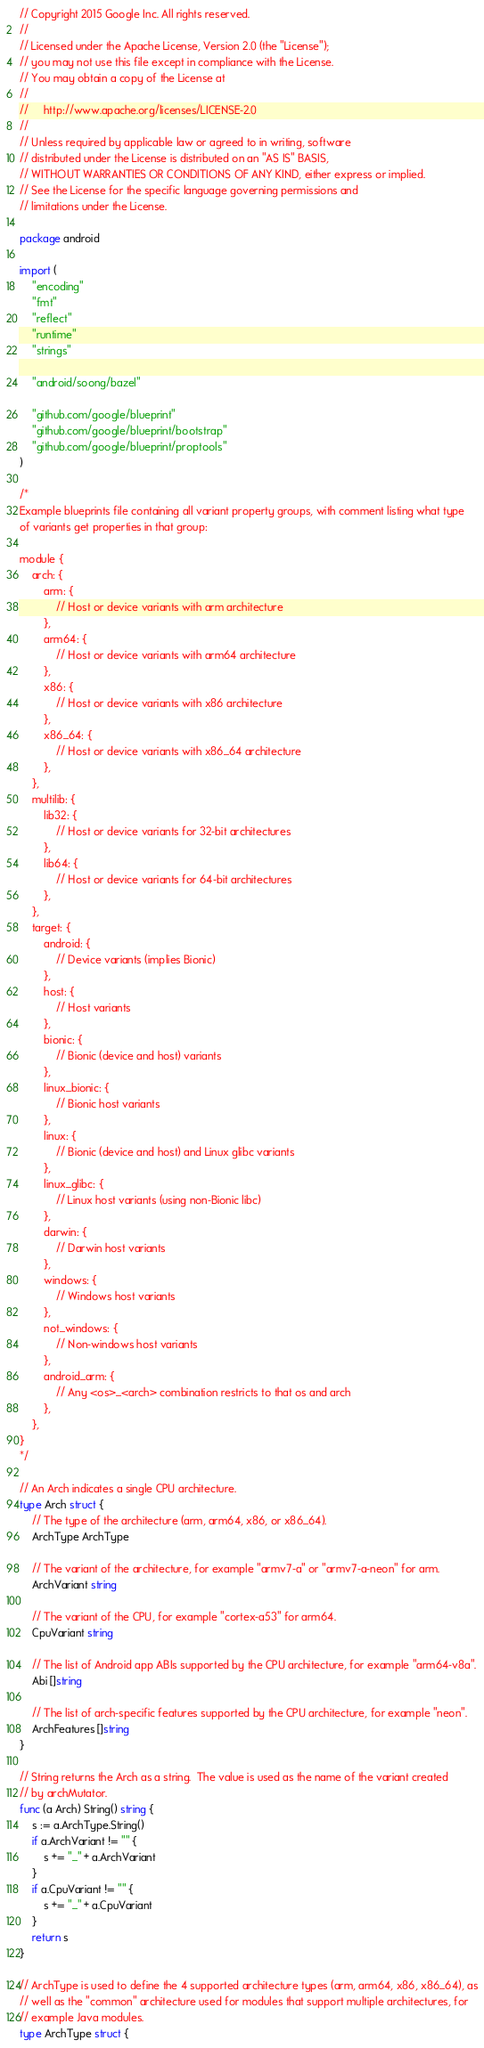<code> <loc_0><loc_0><loc_500><loc_500><_Go_>// Copyright 2015 Google Inc. All rights reserved.
//
// Licensed under the Apache License, Version 2.0 (the "License");
// you may not use this file except in compliance with the License.
// You may obtain a copy of the License at
//
//     http://www.apache.org/licenses/LICENSE-2.0
//
// Unless required by applicable law or agreed to in writing, software
// distributed under the License is distributed on an "AS IS" BASIS,
// WITHOUT WARRANTIES OR CONDITIONS OF ANY KIND, either express or implied.
// See the License for the specific language governing permissions and
// limitations under the License.

package android

import (
	"encoding"
	"fmt"
	"reflect"
	"runtime"
	"strings"

	"android/soong/bazel"

	"github.com/google/blueprint"
	"github.com/google/blueprint/bootstrap"
	"github.com/google/blueprint/proptools"
)

/*
Example blueprints file containing all variant property groups, with comment listing what type
of variants get properties in that group:

module {
    arch: {
        arm: {
            // Host or device variants with arm architecture
        },
        arm64: {
            // Host or device variants with arm64 architecture
        },
        x86: {
            // Host or device variants with x86 architecture
        },
        x86_64: {
            // Host or device variants with x86_64 architecture
        },
    },
    multilib: {
        lib32: {
            // Host or device variants for 32-bit architectures
        },
        lib64: {
            // Host or device variants for 64-bit architectures
        },
    },
    target: {
        android: {
            // Device variants (implies Bionic)
        },
        host: {
            // Host variants
        },
        bionic: {
            // Bionic (device and host) variants
        },
        linux_bionic: {
            // Bionic host variants
        },
        linux: {
            // Bionic (device and host) and Linux glibc variants
        },
        linux_glibc: {
            // Linux host variants (using non-Bionic libc)
        },
        darwin: {
            // Darwin host variants
        },
        windows: {
            // Windows host variants
        },
        not_windows: {
            // Non-windows host variants
        },
        android_arm: {
            // Any <os>_<arch> combination restricts to that os and arch
        },
    },
}
*/

// An Arch indicates a single CPU architecture.
type Arch struct {
	// The type of the architecture (arm, arm64, x86, or x86_64).
	ArchType ArchType

	// The variant of the architecture, for example "armv7-a" or "armv7-a-neon" for arm.
	ArchVariant string

	// The variant of the CPU, for example "cortex-a53" for arm64.
	CpuVariant string

	// The list of Android app ABIs supported by the CPU architecture, for example "arm64-v8a".
	Abi []string

	// The list of arch-specific features supported by the CPU architecture, for example "neon".
	ArchFeatures []string
}

// String returns the Arch as a string.  The value is used as the name of the variant created
// by archMutator.
func (a Arch) String() string {
	s := a.ArchType.String()
	if a.ArchVariant != "" {
		s += "_" + a.ArchVariant
	}
	if a.CpuVariant != "" {
		s += "_" + a.CpuVariant
	}
	return s
}

// ArchType is used to define the 4 supported architecture types (arm, arm64, x86, x86_64), as
// well as the "common" architecture used for modules that support multiple architectures, for
// example Java modules.
type ArchType struct {</code> 